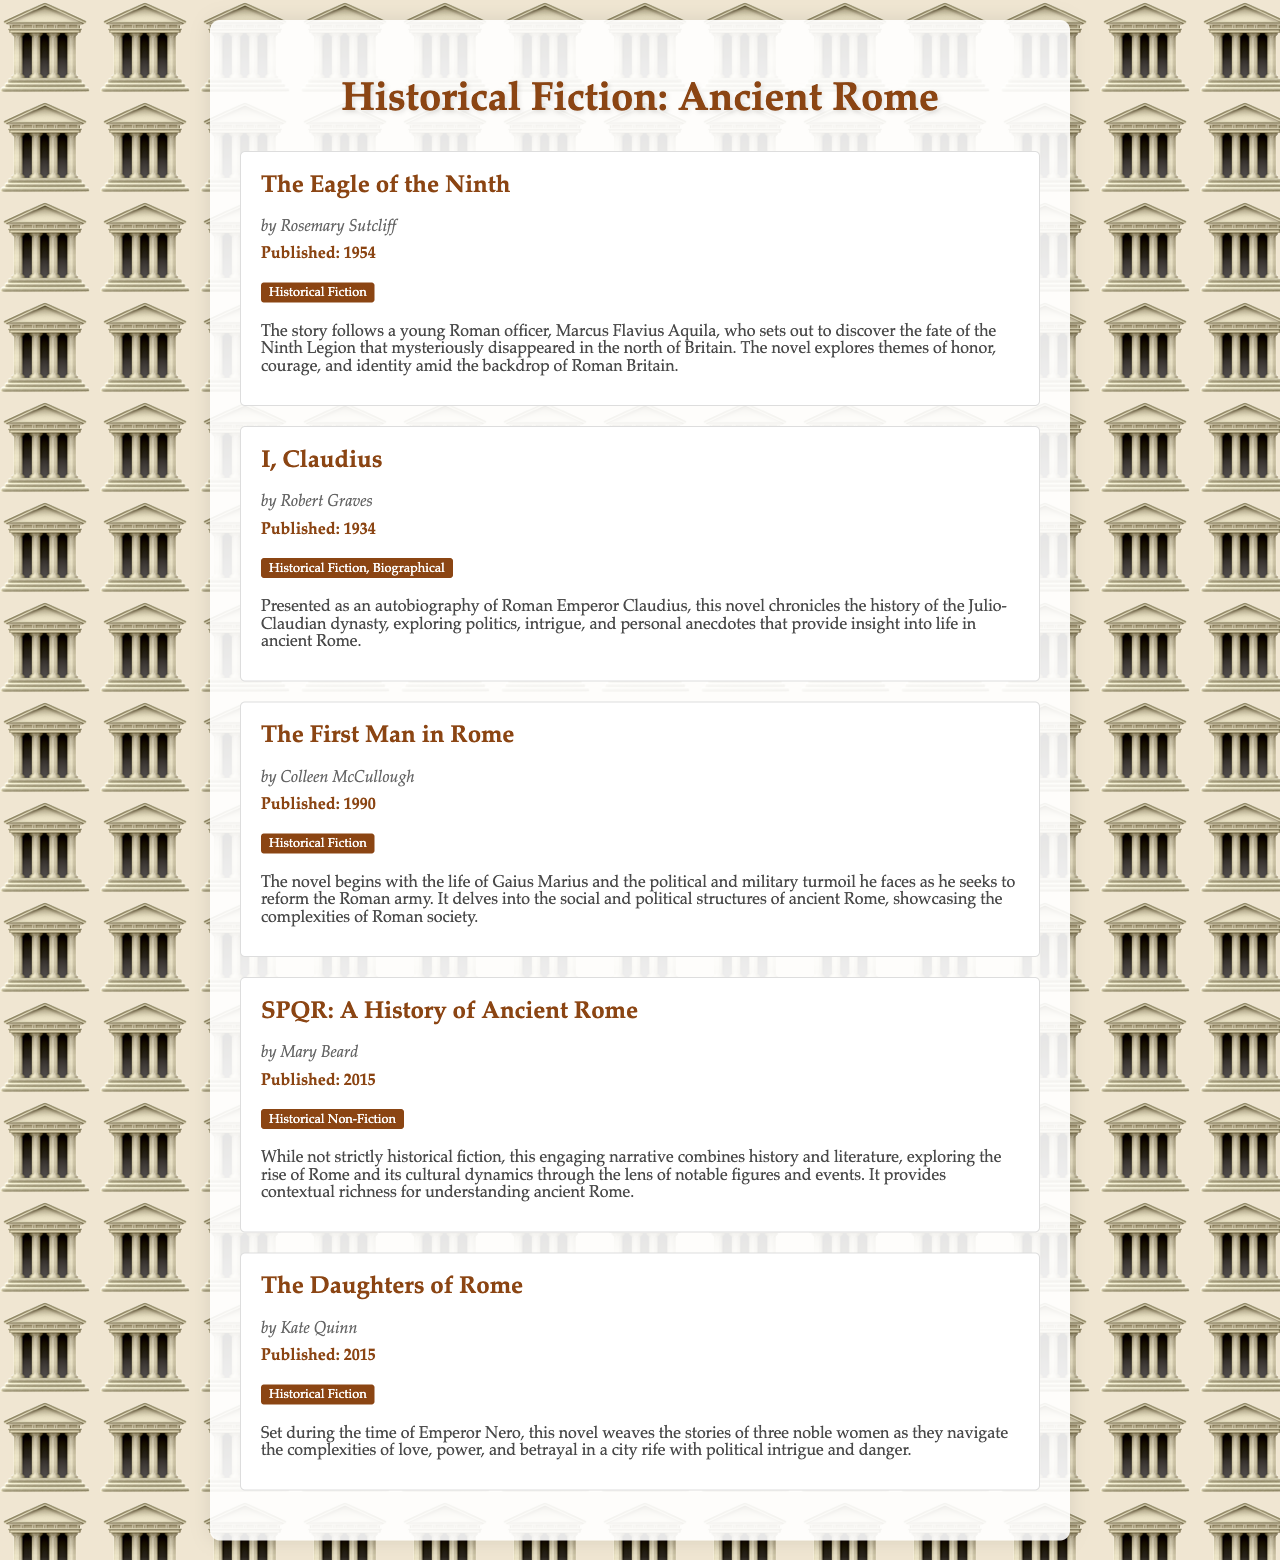What is the title of the first book listed? The first book listed is "The Eagle of the Ninth."
Answer: The Eagle of the Ninth Who is the author of "I, Claudius"? The document states that "I, Claudius" is authored by Robert Graves.
Answer: Robert Graves In which year was "The First Man in Rome" published? The publication year for "The First Man in Rome" is listed in the document as 1990.
Answer: 1990 What genre does "The Daughters of Rome" fall under? According to the document, "The Daughters of Rome" is categorized as Historical Fiction.
Answer: Historical Fiction What is the main theme of "The Eagle of the Ninth"? The document describes the main themes of "The Eagle of the Ninth" as honor, courage, and identity.
Answer: Honor, courage, and identity Which historical period does "The Daughters of Rome" focus on? The novel focuses on the time of Emperor Nero, as stated in the document.
Answer: Time of Emperor Nero How many books listed are classified strictly as Historical Fiction? The document mentions four novels that are classified under Historical Fiction.
Answer: Four What type of book is "SPQR: A History of Ancient Rome"? The document states that "SPQR: A History of Ancient Rome" is classified as Historical Non-Fiction.
Answer: Historical Non-Fiction 